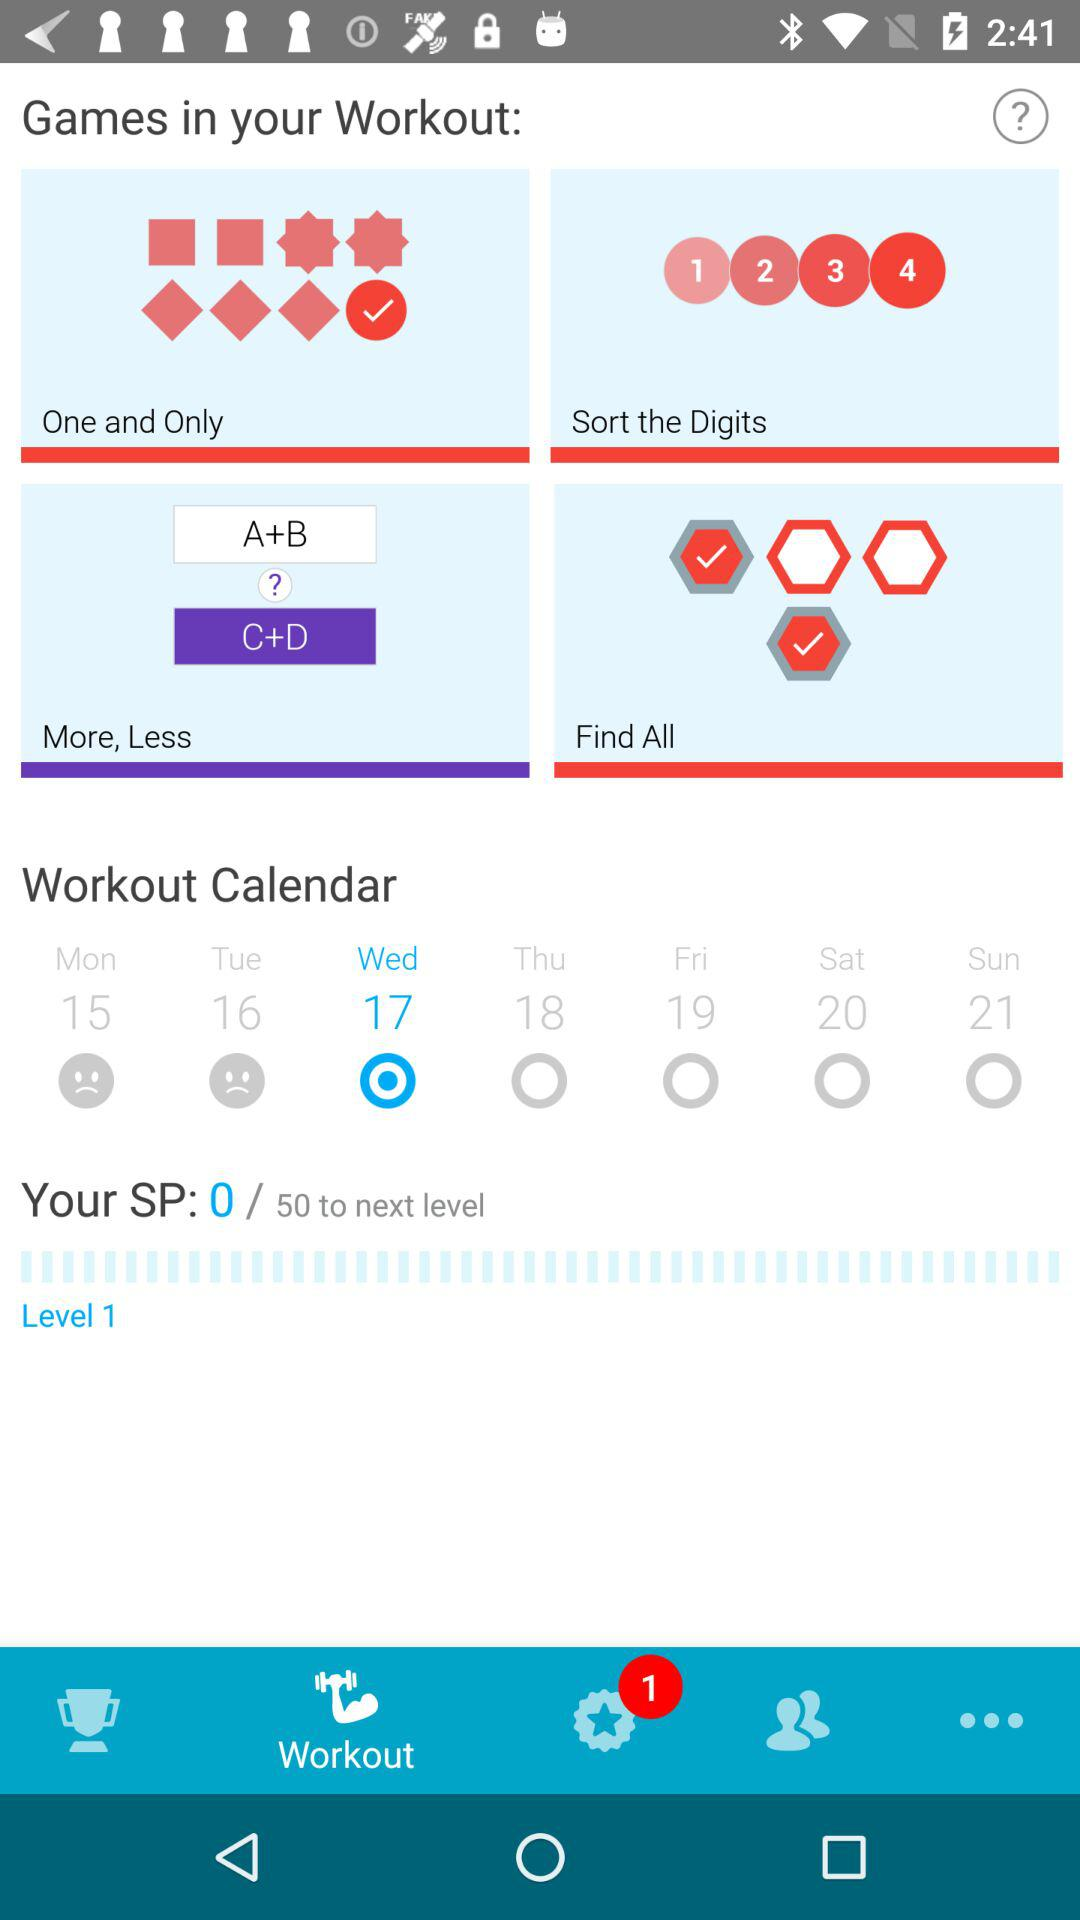What is the SP score? The SP score is 0. 